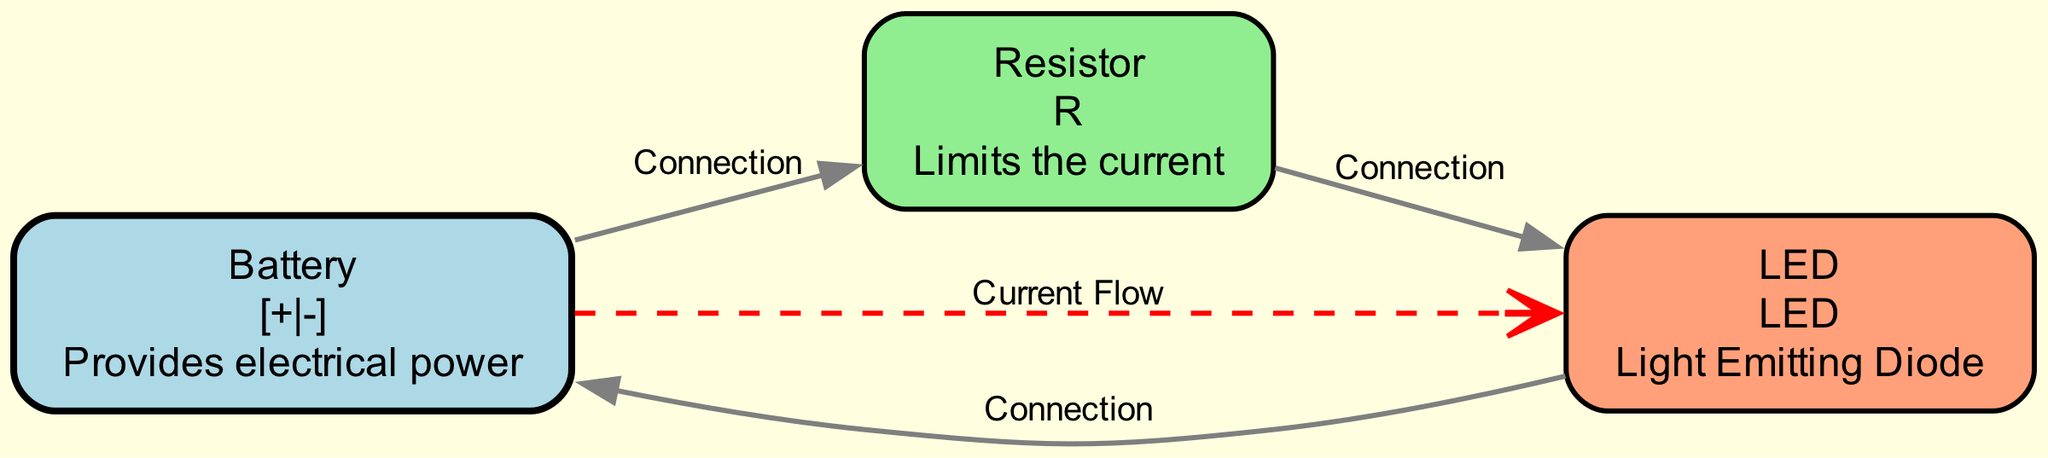How many edges are in the diagram? By counting the connections between the nodes, we find three edges: one connecting the battery to the resistor, one connecting the resistor to the LED, and one connecting the LED back to the battery. Therefore, the total number of edges is three.
Answer: 3 What does the LED represent in the circuit? The LED in the diagram is described as a "Light Emitting Diode". This description is located in the node labeled "LED", which clearly conveys its function in the circuit.
Answer: Light Emitting Diode What is the direction of current flow? The current flow in the diagram is shown from the battery to the LED, as indicated by the dashed red line labeled "Current Flow". This line clearly depicts the intended path of current in the circuit.
Answer: From battery to LED Which component limits the current? The resistor is designated in the diagram as the component that "Limits the current". This information is contained in the node labeled "Resistor", which outlines its role in the electrical circuit.
Answer: Resistor If the battery voltage is increased, what is the expected effect on current flow? Increasing the battery voltage will typically lead to an increase in current flow through the circuit, as Ohm's Law states that current (I) is directly proportional to voltage (V) over resistance (R). This reasoning is based on the fundamental principles of electrical circuits shown in the diagram.
Answer: Increase in current flow What color is used for the LED representation? The LED node is depicted in "lightsalmon" color, as specified in the code that styles the diagram elements. This color choice is noted within the node's styling attributes.
Answer: lightsalmon How does the resistor connect to the LED? The resistor is connected to the LED via a wire, as shown by the edge labeled "Connection" that links the two nodes together. This connection is clearly indicated in the diagram with an edge that visually represents the physical connection.
Answer: Wires connecting Resistor to LED 